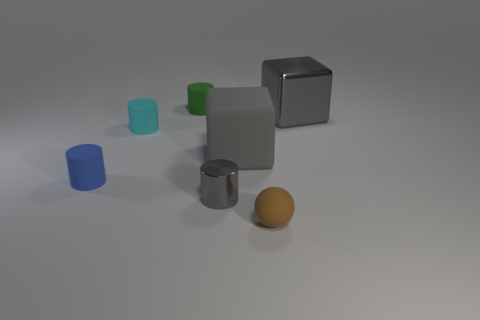Subtract all rubber cylinders. How many cylinders are left? 1 Subtract all green cylinders. How many cylinders are left? 3 Add 1 tiny cylinders. How many objects exist? 8 Subtract all purple cylinders. Subtract all matte balls. How many objects are left? 6 Add 4 cyan matte objects. How many cyan matte objects are left? 5 Add 2 brown spheres. How many brown spheres exist? 3 Subtract 1 gray cylinders. How many objects are left? 6 Subtract all cylinders. How many objects are left? 3 Subtract 2 blocks. How many blocks are left? 0 Subtract all gray cylinders. Subtract all yellow cubes. How many cylinders are left? 3 